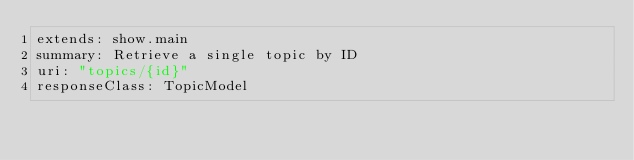Convert code to text. <code><loc_0><loc_0><loc_500><loc_500><_YAML_>extends: show.main
summary: Retrieve a single topic by ID
uri: "topics/{id}"
responseClass: TopicModel
</code> 